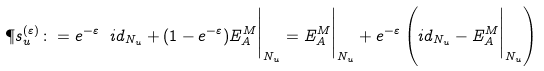<formula> <loc_0><loc_0><loc_500><loc_500>\P s _ { u } ^ { ( \varepsilon ) } \colon = e ^ { - \varepsilon } \ i d _ { N _ { u } } + ( 1 - e ^ { - \varepsilon } ) E _ { A } ^ { M } \Big | _ { N _ { u } } = E _ { A } ^ { M } \Big | _ { N _ { u } } + e ^ { - \varepsilon } \left ( i d _ { N _ { u } } - E _ { A } ^ { M } \Big | _ { N _ { u } } \right )</formula> 